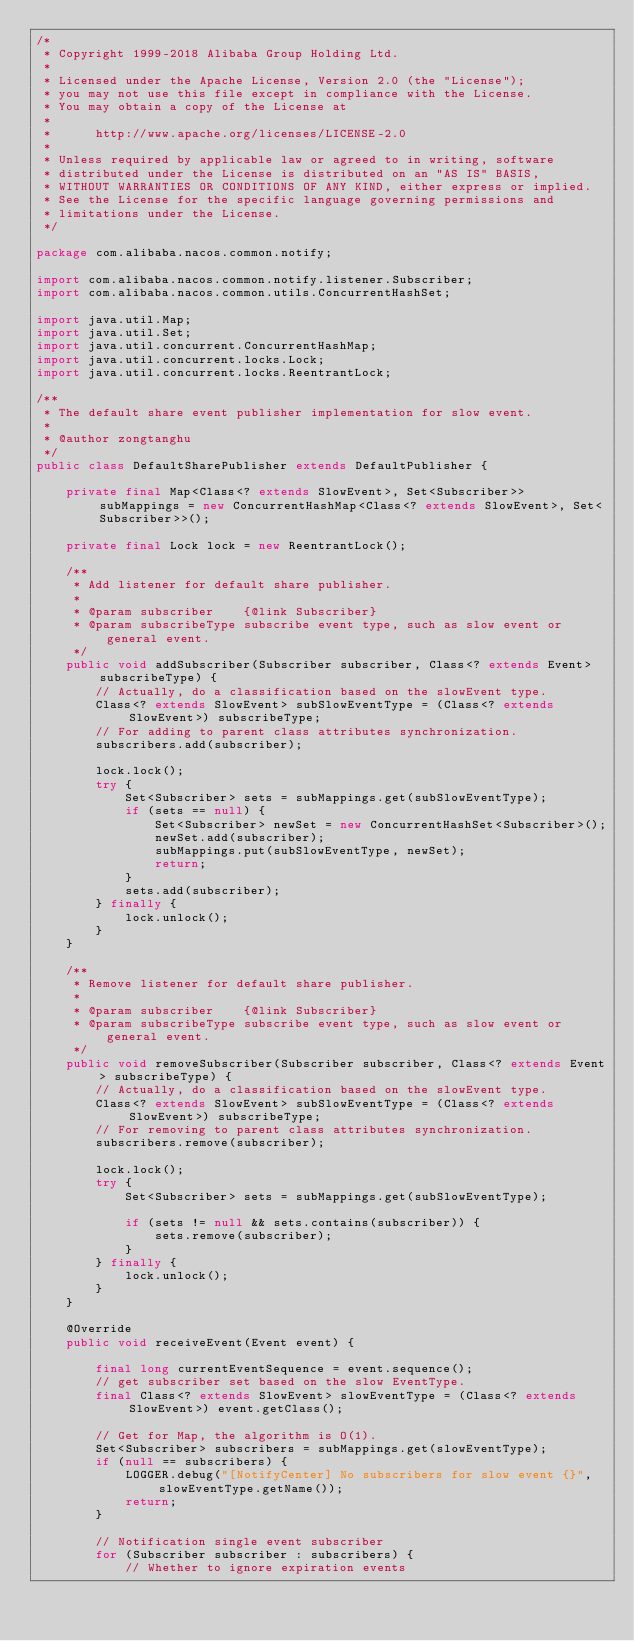<code> <loc_0><loc_0><loc_500><loc_500><_Java_>/*
 * Copyright 1999-2018 Alibaba Group Holding Ltd.
 *
 * Licensed under the Apache License, Version 2.0 (the "License");
 * you may not use this file except in compliance with the License.
 * You may obtain a copy of the License at
 *
 *      http://www.apache.org/licenses/LICENSE-2.0
 *
 * Unless required by applicable law or agreed to in writing, software
 * distributed under the License is distributed on an "AS IS" BASIS,
 * WITHOUT WARRANTIES OR CONDITIONS OF ANY KIND, either express or implied.
 * See the License for the specific language governing permissions and
 * limitations under the License.
 */

package com.alibaba.nacos.common.notify;

import com.alibaba.nacos.common.notify.listener.Subscriber;
import com.alibaba.nacos.common.utils.ConcurrentHashSet;

import java.util.Map;
import java.util.Set;
import java.util.concurrent.ConcurrentHashMap;
import java.util.concurrent.locks.Lock;
import java.util.concurrent.locks.ReentrantLock;

/**
 * The default share event publisher implementation for slow event.
 *
 * @author zongtanghu
 */
public class DefaultSharePublisher extends DefaultPublisher {

    private final Map<Class<? extends SlowEvent>, Set<Subscriber>> subMappings = new ConcurrentHashMap<Class<? extends SlowEvent>, Set<Subscriber>>();

    private final Lock lock = new ReentrantLock();

    /**
     * Add listener for default share publisher.
     *
     * @param subscriber    {@link Subscriber}
     * @param subscribeType subscribe event type, such as slow event or general event.
     */
    public void addSubscriber(Subscriber subscriber, Class<? extends Event> subscribeType) {
        // Actually, do a classification based on the slowEvent type.
        Class<? extends SlowEvent> subSlowEventType = (Class<? extends SlowEvent>) subscribeType;
        // For adding to parent class attributes synchronization.
        subscribers.add(subscriber);

        lock.lock();
        try {
            Set<Subscriber> sets = subMappings.get(subSlowEventType);
            if (sets == null) {
                Set<Subscriber> newSet = new ConcurrentHashSet<Subscriber>();
                newSet.add(subscriber);
                subMappings.put(subSlowEventType, newSet);
                return;
            }
            sets.add(subscriber);
        } finally {
            lock.unlock();
        }
    }

    /**
     * Remove listener for default share publisher.
     *
     * @param subscriber    {@link Subscriber}
     * @param subscribeType subscribe event type, such as slow event or general event.
     */
    public void removeSubscriber(Subscriber subscriber, Class<? extends Event> subscribeType) {
        // Actually, do a classification based on the slowEvent type.
        Class<? extends SlowEvent> subSlowEventType = (Class<? extends SlowEvent>) subscribeType;
        // For removing to parent class attributes synchronization.
        subscribers.remove(subscriber);

        lock.lock();
        try {
            Set<Subscriber> sets = subMappings.get(subSlowEventType);

            if (sets != null && sets.contains(subscriber)) {
                sets.remove(subscriber);
            }
        } finally {
            lock.unlock();
        }
    }

    @Override
    public void receiveEvent(Event event) {

        final long currentEventSequence = event.sequence();
        // get subscriber set based on the slow EventType.
        final Class<? extends SlowEvent> slowEventType = (Class<? extends SlowEvent>) event.getClass();

        // Get for Map, the algorithm is O(1).
        Set<Subscriber> subscribers = subMappings.get(slowEventType);
        if (null == subscribers) {
            LOGGER.debug("[NotifyCenter] No subscribers for slow event {}", slowEventType.getName());
            return;
        }

        // Notification single event subscriber
        for (Subscriber subscriber : subscribers) {
            // Whether to ignore expiration events</code> 